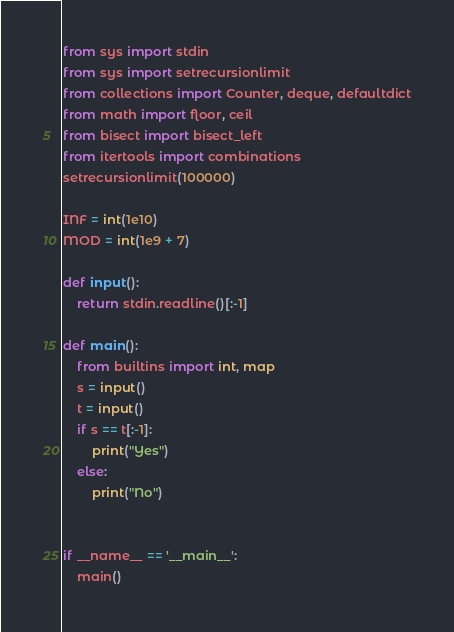<code> <loc_0><loc_0><loc_500><loc_500><_Python_>from sys import stdin
from sys import setrecursionlimit
from collections import Counter, deque, defaultdict
from math import floor, ceil
from bisect import bisect_left
from itertools import combinations
setrecursionlimit(100000)

INF = int(1e10)
MOD = int(1e9 + 7)

def input():
    return stdin.readline()[:-1]

def main():
    from builtins import int, map
    s = input()
    t = input()
    if s == t[:-1]:
        print("Yes")
    else:
        print("No")


if __name__ == '__main__':
    main()</code> 